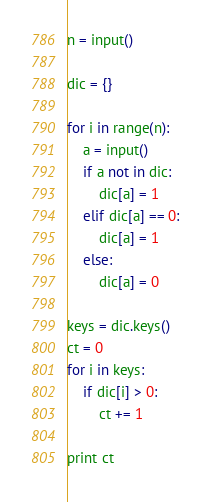Convert code to text. <code><loc_0><loc_0><loc_500><loc_500><_Python_>n = input()

dic = {}

for i in range(n):
    a = input()
    if a not in dic:
        dic[a] = 1
    elif dic[a] == 0:
        dic[a] = 1
    else:
        dic[a] = 0

keys = dic.keys()
ct = 0
for i in keys:
    if dic[i] > 0:
        ct += 1

print ct</code> 